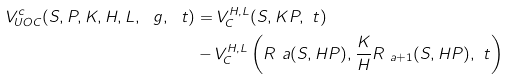<formula> <loc_0><loc_0><loc_500><loc_500>V _ { U O C } ^ { c } ( S , P , K , H , L , \ g , \ t ) & = V _ { C } ^ { H , L } ( S , K P , \ t ) \\ & - V _ { C } ^ { H , L } \left ( R _ { \ } a ( S , H P ) , \frac { K } { H } R _ { \ a + 1 } ( S , H P ) , \ t \right )</formula> 